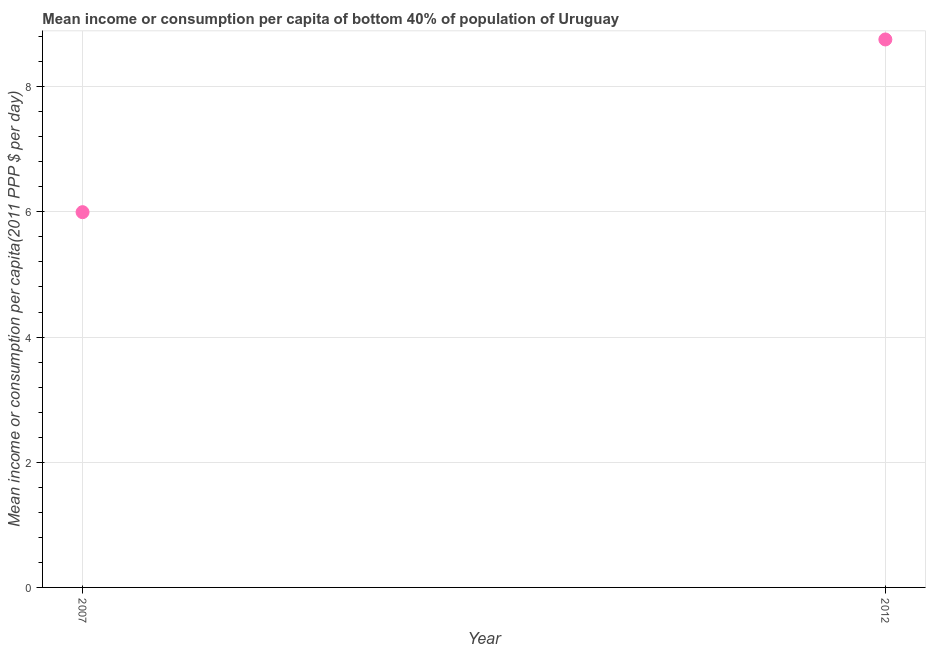What is the mean income or consumption in 2007?
Provide a short and direct response. 6. Across all years, what is the maximum mean income or consumption?
Ensure brevity in your answer.  8.75. Across all years, what is the minimum mean income or consumption?
Offer a very short reply. 6. What is the sum of the mean income or consumption?
Keep it short and to the point. 14.75. What is the difference between the mean income or consumption in 2007 and 2012?
Your answer should be very brief. -2.76. What is the average mean income or consumption per year?
Provide a short and direct response. 7.38. What is the median mean income or consumption?
Your answer should be very brief. 7.38. In how many years, is the mean income or consumption greater than 1.6 $?
Your response must be concise. 2. What is the ratio of the mean income or consumption in 2007 to that in 2012?
Your answer should be very brief. 0.68. Is the mean income or consumption in 2007 less than that in 2012?
Your response must be concise. Yes. Does the mean income or consumption monotonically increase over the years?
Provide a succinct answer. Yes. How many dotlines are there?
Ensure brevity in your answer.  1. What is the title of the graph?
Your answer should be very brief. Mean income or consumption per capita of bottom 40% of population of Uruguay. What is the label or title of the Y-axis?
Provide a succinct answer. Mean income or consumption per capita(2011 PPP $ per day). What is the Mean income or consumption per capita(2011 PPP $ per day) in 2007?
Provide a succinct answer. 6. What is the Mean income or consumption per capita(2011 PPP $ per day) in 2012?
Provide a short and direct response. 8.75. What is the difference between the Mean income or consumption per capita(2011 PPP $ per day) in 2007 and 2012?
Offer a terse response. -2.76. What is the ratio of the Mean income or consumption per capita(2011 PPP $ per day) in 2007 to that in 2012?
Make the answer very short. 0.69. 